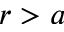<formula> <loc_0><loc_0><loc_500><loc_500>r > a</formula> 